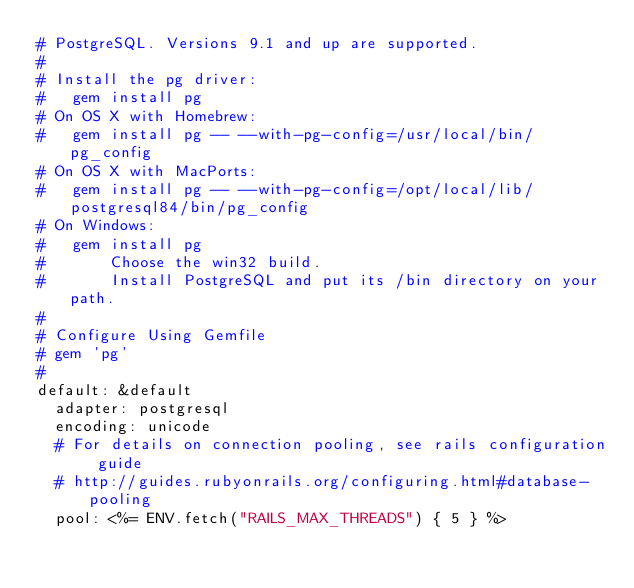<code> <loc_0><loc_0><loc_500><loc_500><_YAML_># PostgreSQL. Versions 9.1 and up are supported.
#
# Install the pg driver:
#   gem install pg
# On OS X with Homebrew:
#   gem install pg -- --with-pg-config=/usr/local/bin/pg_config
# On OS X with MacPorts:
#   gem install pg -- --with-pg-config=/opt/local/lib/postgresql84/bin/pg_config
# On Windows:
#   gem install pg
#       Choose the win32 build.
#       Install PostgreSQL and put its /bin directory on your path.
#
# Configure Using Gemfile
# gem 'pg'
#
default: &default
  adapter: postgresql
  encoding: unicode
  # For details on connection pooling, see rails configuration guide
  # http://guides.rubyonrails.org/configuring.html#database-pooling
  pool: <%= ENV.fetch("RAILS_MAX_THREADS") { 5 } %>
</code> 